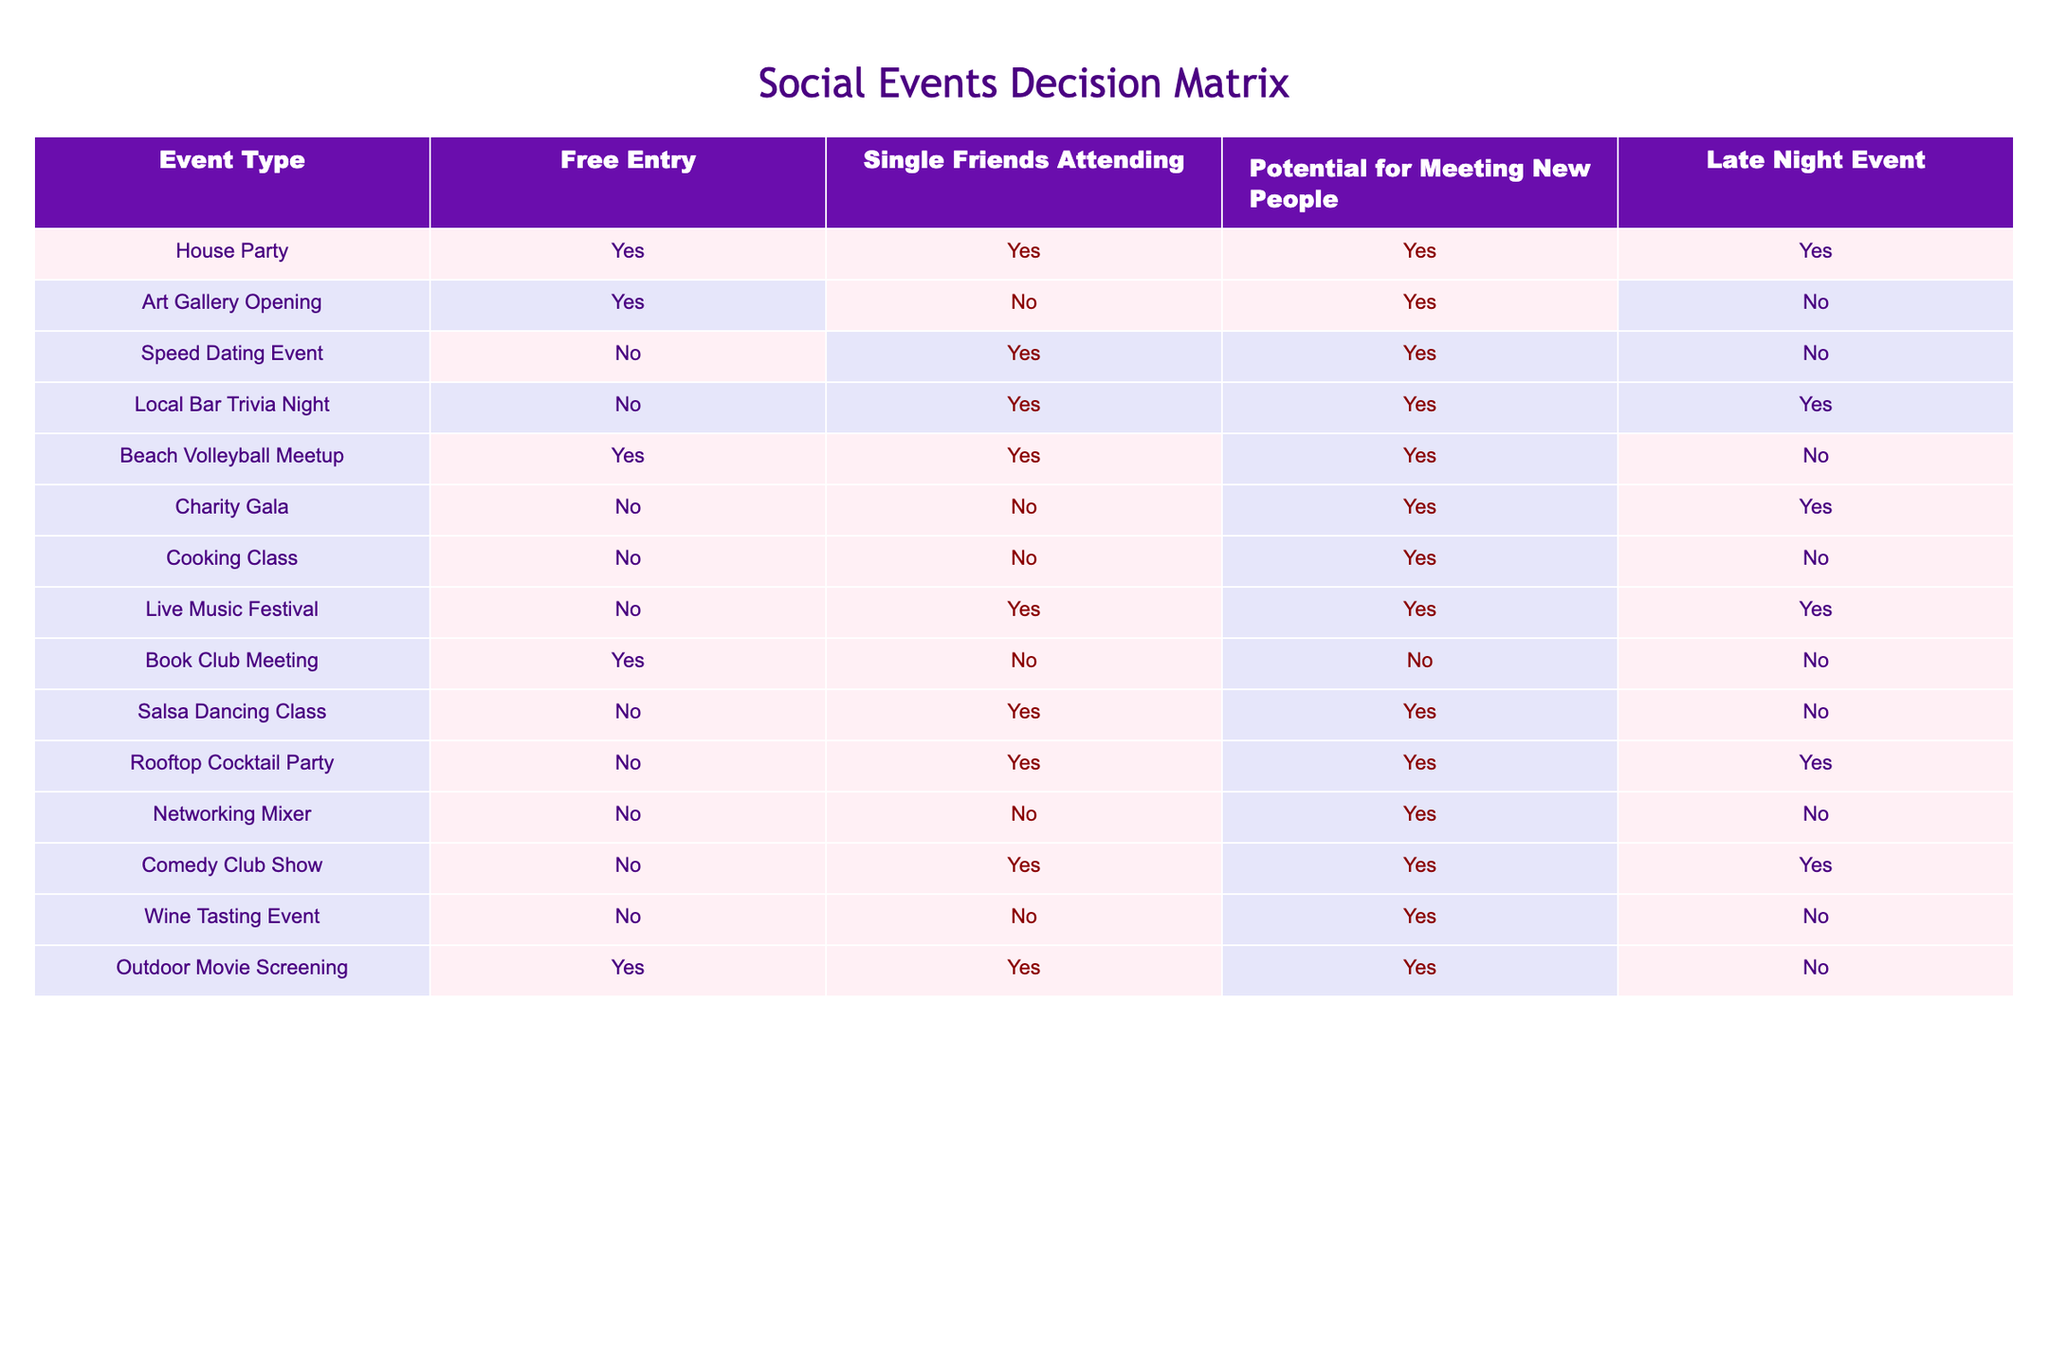What social event has free entry and the potential for meeting new people? By looking at the table, we can identify events that are marked as "Yes" under both the Free Entry and Potential for Meeting New People columns. The events that meet these criteria are the House Party, Beach Volleyball Meetup, and Outdoor Movie Screening.
Answer: House Party, Beach Volleyball Meetup, Outdoor Movie Screening Is the Salsa Dancing Class a late-night event? The Salsa Dancing Class is listed under the Late Night Event column with a "No" value. Therefore, it is not a late-night event.
Answer: No What is the total number of events with single friends attending? We can count the events marked as "Yes" under the Single Friends Attending column. There are a total of 7 events (House Party, Speed Dating Event, Local Bar Trivia Night, Beach Volleyball Meetup, Rooftop Cocktail Party, Comedy Club Show, and Outdoor Movie Screening) that meet this condition.
Answer: 7 Which events have free entry and do not have single friends attending? We can filter the table for those events with "Yes" in Free Entry but "No" in Single Friends Attending. The only event that fits this description is the Art Gallery Opening.
Answer: Art Gallery Opening Are there any events that allow for meeting new people but do not provide free entry? We need to look for events that have "Yes" under Potential for Meeting New People but "No" under Free Entry. The events that fit these criteria are the Charity Gala, Cooking Class, Live Music Festival, and Wine Tasting Event.
Answer: Charity Gala, Cooking Class, Live Music Festival, Wine Tasting Event How many late-night events allow for meeting new people? We need to count the events that have "Yes" in the Potential for Meeting New People column and "Yes" in the Late Night Event column. These events are the Local Bar Trivia Night, Live Music Festival, Rooftop Cocktail Party, and Comedy Club Show, giving us a total of 4.
Answer: 4 Is there a social event that is both a late-night event and has a free entry? By checking the table, the House Party and Outdoor Movie Screening are both "Yes" under Free Entry and Late Night Event. Therefore, these two events fit the criteria.
Answer: House Party, Outdoor Movie Screening What percentage of events provide free entry? There are 8 events that provide free entry out of a total of 15 events. To find the percentage, we divide 8 by 15 and multiply by 100, yielding approximately 53.33%.
Answer: 53.33% 